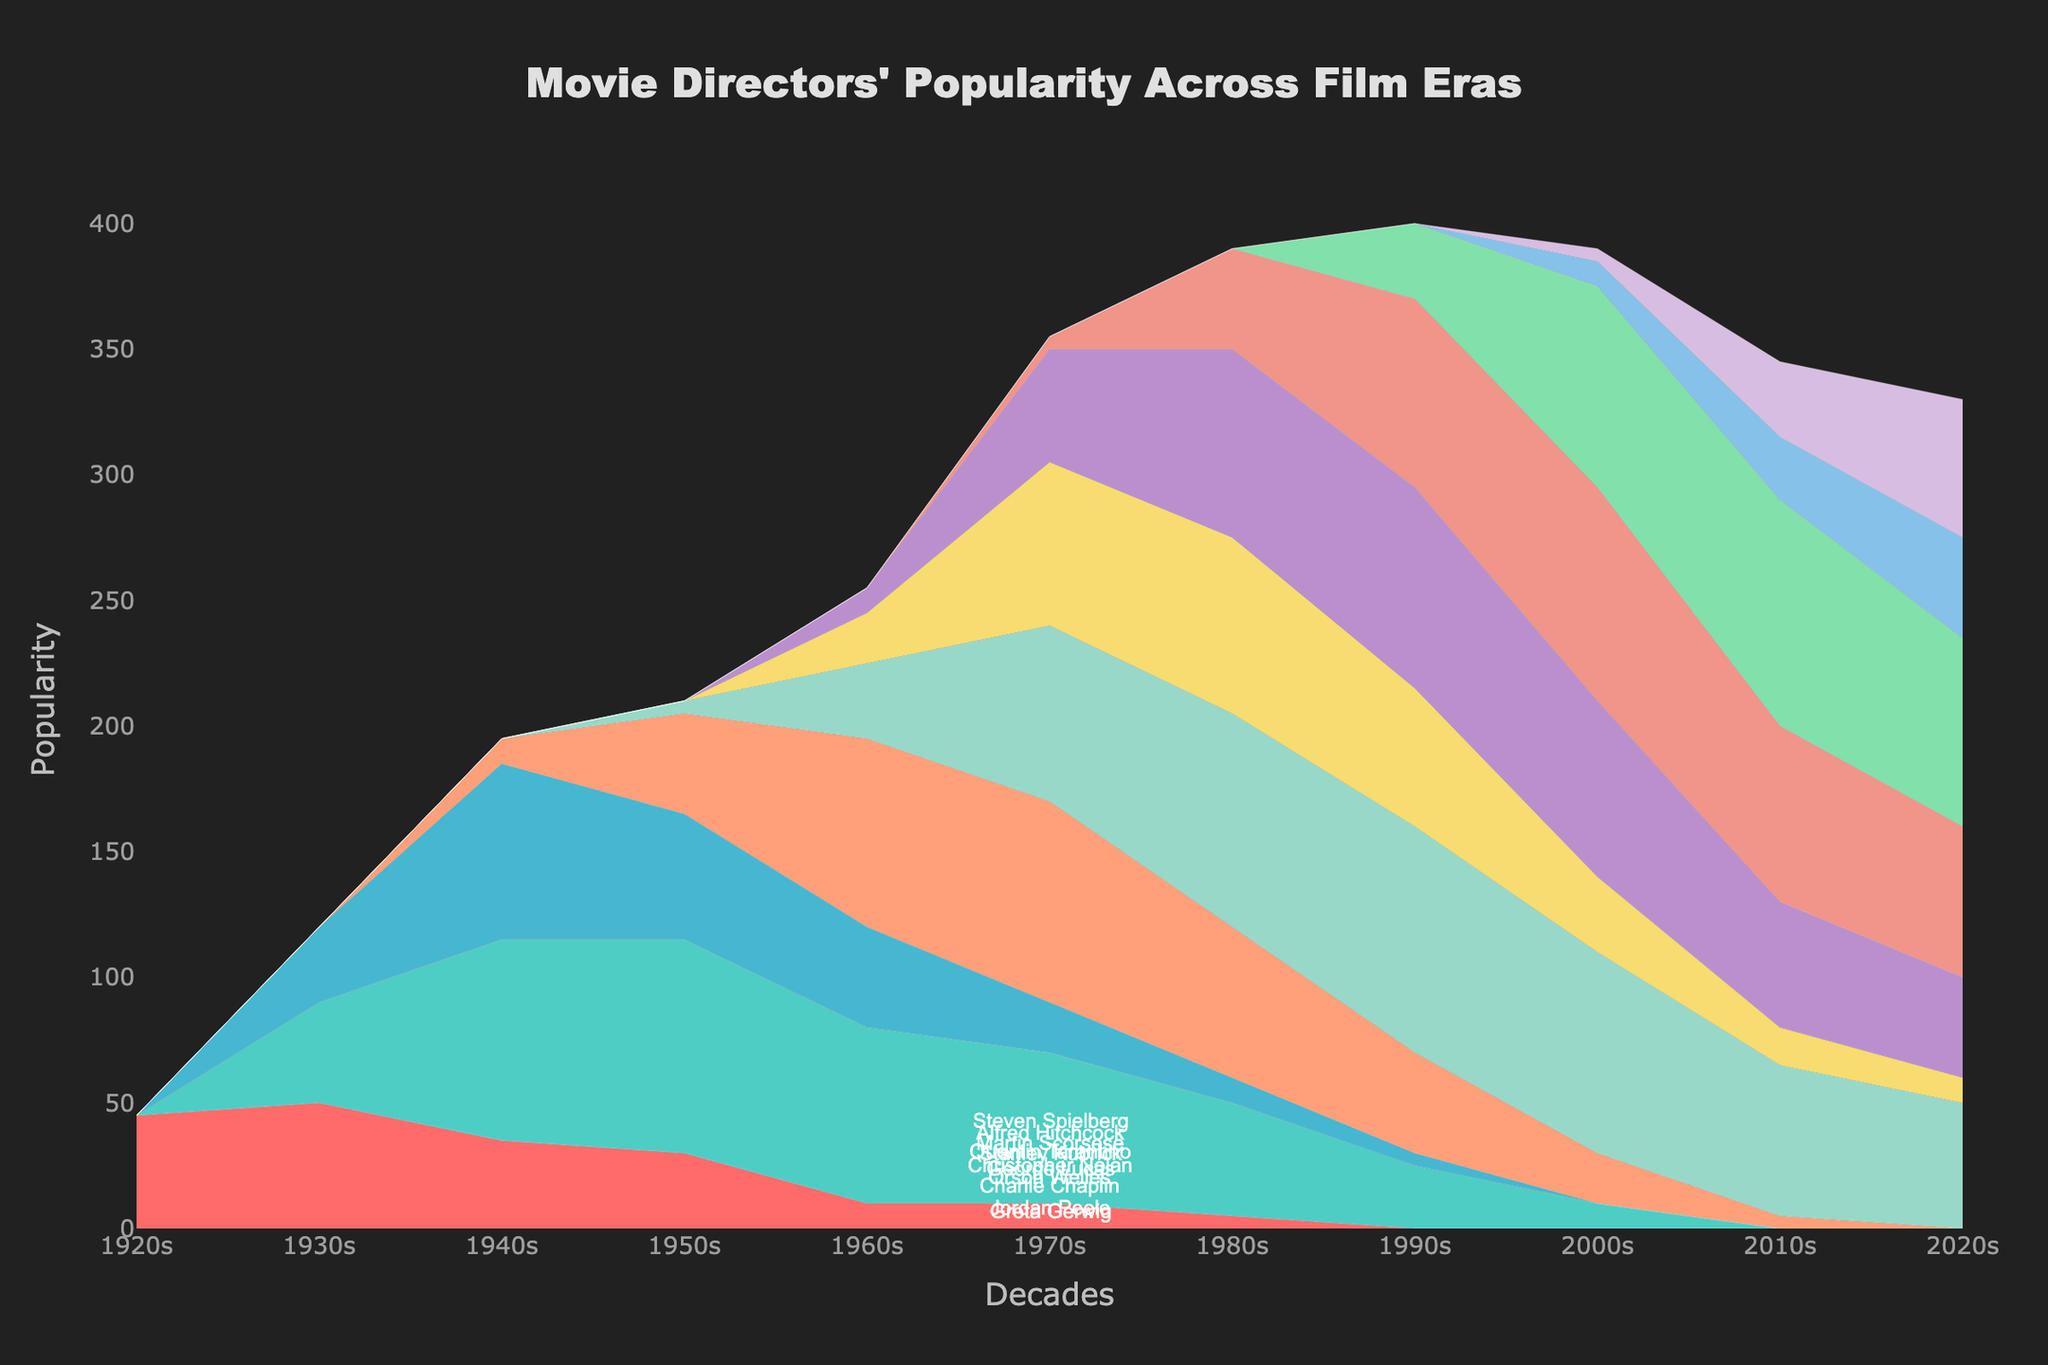What is the title of the figure? The title is displayed at the top of the figure.
Answer: Movie Directors' Popularity Across Film Eras Which decade does Alfred Hitchcock reach his peak popularity? To find this, look at the stream representing Alfred Hitchcock and identify the highest point on the y-axis. This occurs in the 1950s.
Answer: 1950s What is the popularity score of Orson Welles in the 2000s? Locate the stream for Orson Welles, follow it to the 2000s, and read the value on the y-axis, which is 0.
Answer: 0 How many directors have some popularity in the 1920s? Check the initial decade for any streams that are not at 0. Only Charlie Chaplin has a value above 0 in the 1920s.
Answer: 1 How did the popularity of Steven Spielberg change from the 1980s to the 2010s? Identify Steven Spielberg's stream and compare the y-axis values from the 1980s, 1990s, 2000s to the 2010s. Spielberg’s popularity increases from 70 in the 1980s, peaks at 90 in the 1990s, then drops to 80 in the 2000s, and 60 in the 2010s.
Answer: Peaked in the 1990s and then declined Who has the highest popularity score in the 2010s? Compare the popularity scores of each director for the 2010s. Christopher Nolan has the highest value at 90.
Answer: Christopher Nolan Between Martin Scorsese and George Lucas, who had a higher popularity in the 1970s? Compare the y-axis values for both directors in the 1970s. Martin Scorsese has a popularity score of 45, while George Lucas has a score of 65.
Answer: George Lucas Sum the popularity scores of Charlie Chaplin in all decades. Add the scores from all decades for Charlie Chaplin: 45 + 50 + 35 + 30 + 10 + 10 + 5 + 0 + 0 + 0 + 0 = 185.
Answer: 185 Find the average popularity of Quentin Tarantino across all decades. Add the values for Quentin Tarantino and divide by the number of decades (11): (0 + 0 + 0 + 0 + 0 + 5 + 40 + 75 + 85 + 70 + 60) / 11 = 335 / 11 ≈ 30.45.
Answer: 30.45 Which two directors had increasing popularity in every decade they were active? Identify directors whose values consistently increase in each decade they appear: Jordan Peele and Greta Gerwig show continuous increases without any decline.
Answer: Jordan Peele, Greta Gerwig 